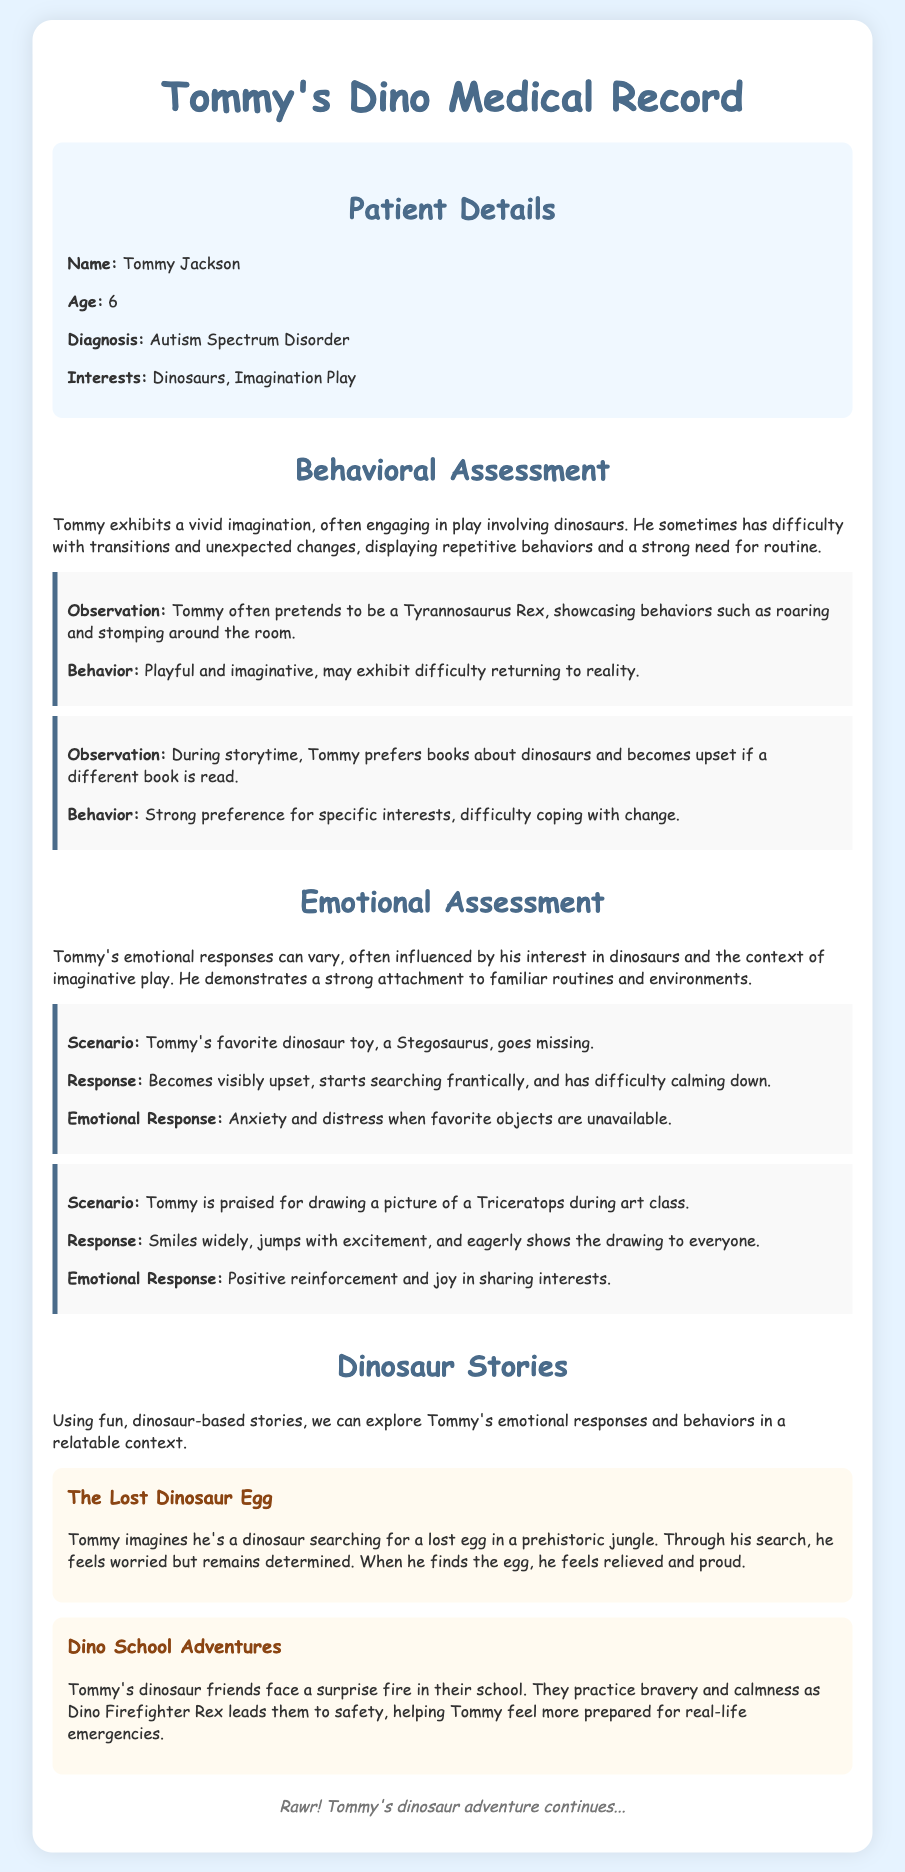What is Tommy's age? Tommy's age is specified in the patient details section of the document.
Answer: 6 What is Tommy's favorite dinosaur? The observations indicate that Tommy enjoys pretending to be a Tyrannosaurus Rex.
Answer: Tyrannosaurus Rex What happens when Tommy's Stegosaurus toy goes missing? The scenario describes Tommy's response to the loss of his toy, providing insight into his emotional state.
Answer: Becomes visibly upset How does Tommy react to praise in art class? The emotional assessment mentions Tommy's reaction when praised for his drawing.
Answer: Smiles widely What is the title of the first dinosaur story? The titles of the stories are listed under the Dinosaur Stories section.
Answer: The Lost Dinosaur Egg What emotional response does Tommy show during a missing toy scenario? This is found in the scenario description that details Tommy's emotional state.
Answer: Anxiety and distress What does Tommy's favorite dinosaur toy represent in his assessment? The document notes the attachment and emotional response related to a favorite object.
Answer: Familiar routines Who leads Tommy's dinosaur friends to safety in the dino school story? The story mentions a character that plays a crucial role in their adventure.
Answer: Dino Firefighter Rex 